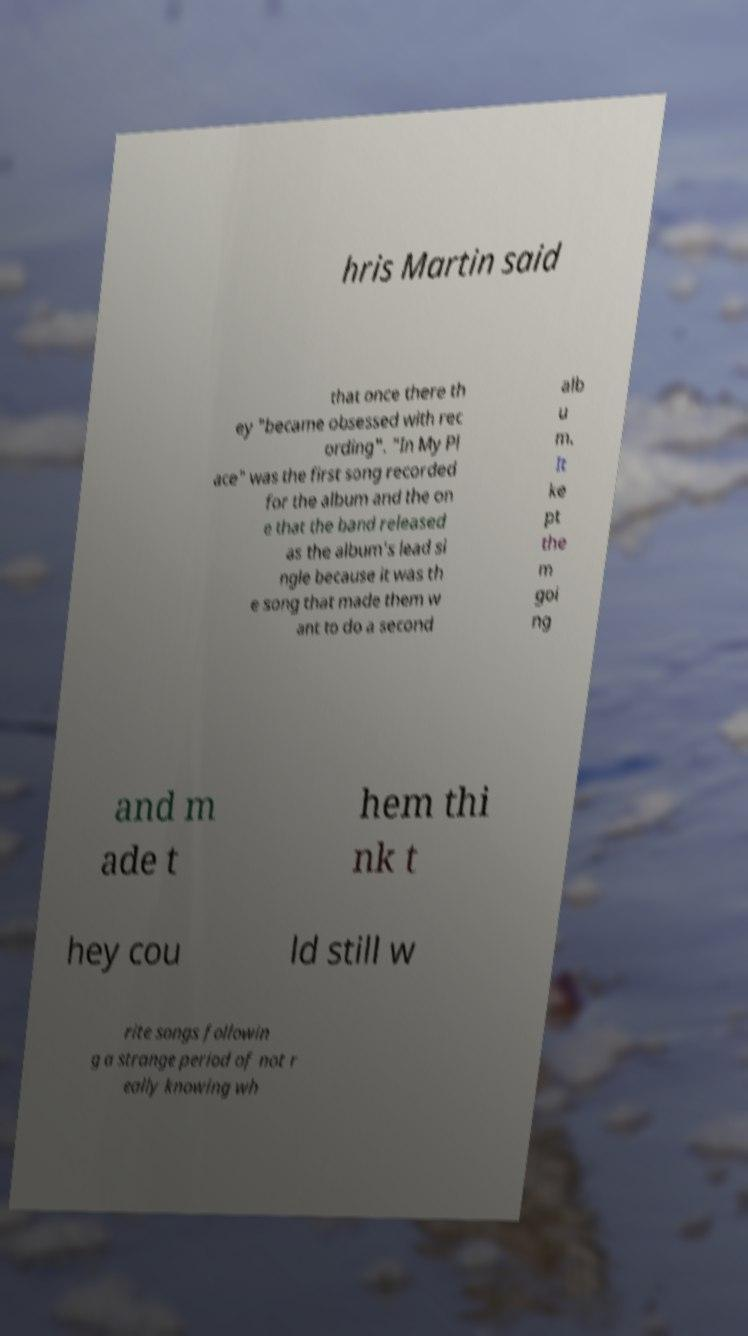There's text embedded in this image that I need extracted. Can you transcribe it verbatim? hris Martin said that once there th ey "became obsessed with rec ording". "In My Pl ace" was the first song recorded for the album and the on e that the band released as the album's lead si ngle because it was th e song that made them w ant to do a second alb u m. It ke pt the m goi ng and m ade t hem thi nk t hey cou ld still w rite songs followin g a strange period of not r eally knowing wh 